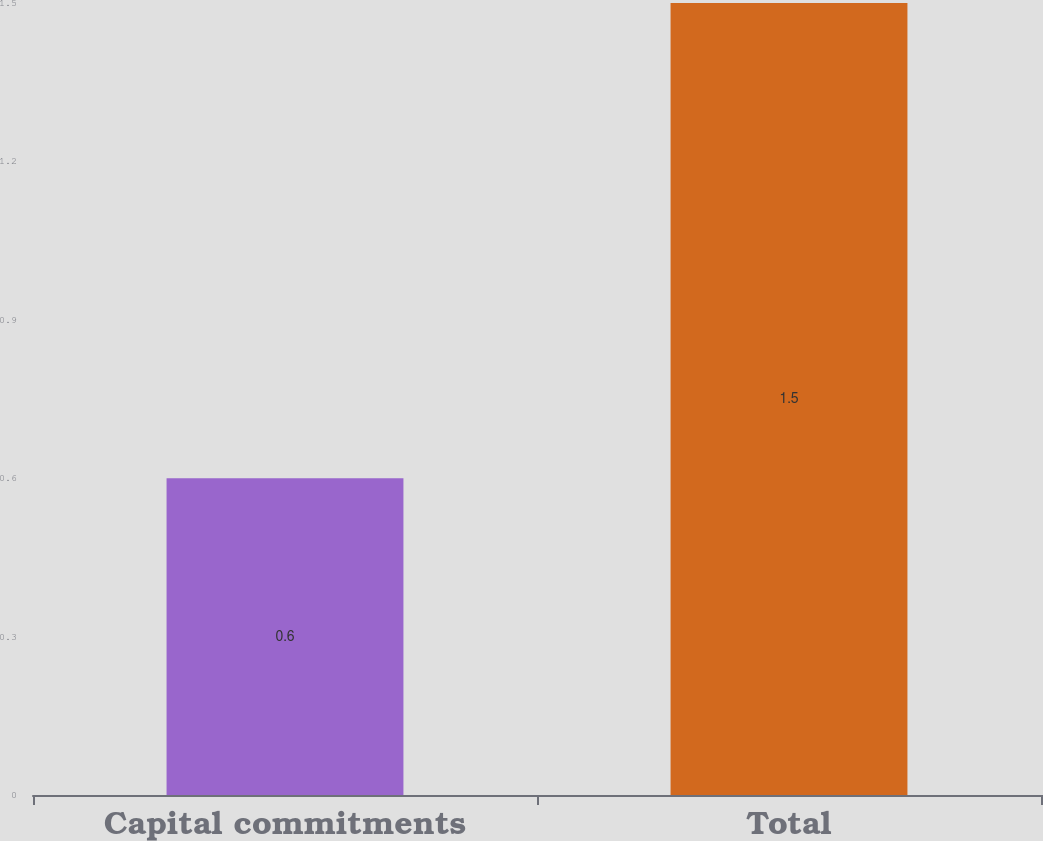Convert chart. <chart><loc_0><loc_0><loc_500><loc_500><bar_chart><fcel>Capital commitments<fcel>Total<nl><fcel>0.6<fcel>1.5<nl></chart> 